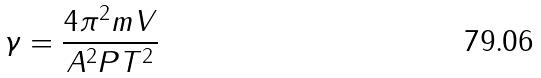<formula> <loc_0><loc_0><loc_500><loc_500>\gamma = \frac { 4 \pi ^ { 2 } m V } { A ^ { 2 } P T ^ { 2 } }</formula> 